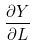Convert formula to latex. <formula><loc_0><loc_0><loc_500><loc_500>\frac { \partial Y } { \partial L }</formula> 